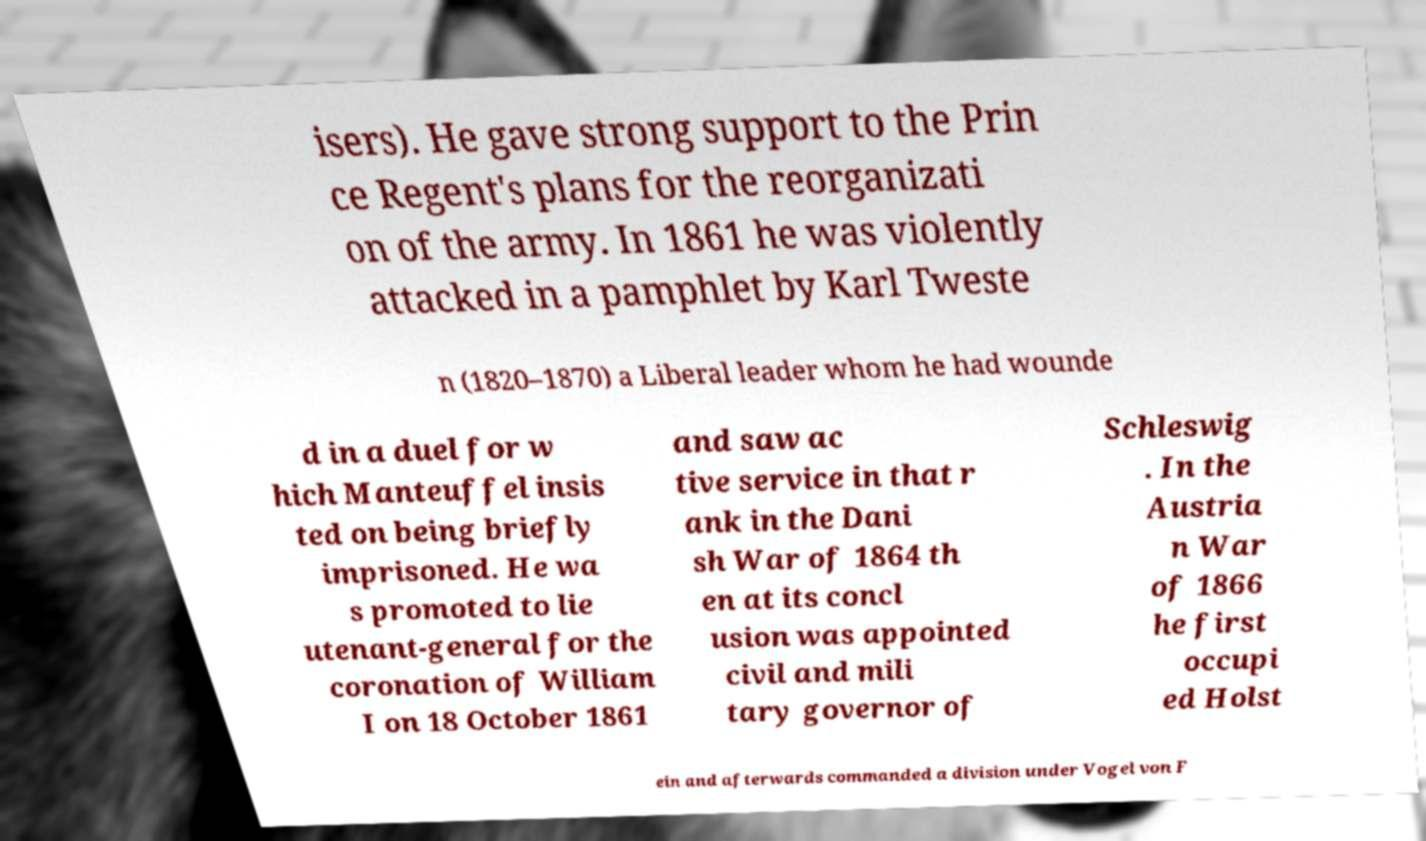What messages or text are displayed in this image? I need them in a readable, typed format. isers). He gave strong support to the Prin ce Regent's plans for the reorganizati on of the army. In 1861 he was violently attacked in a pamphlet by Karl Tweste n (1820–1870) a Liberal leader whom he had wounde d in a duel for w hich Manteuffel insis ted on being briefly imprisoned. He wa s promoted to lie utenant-general for the coronation of William I on 18 October 1861 and saw ac tive service in that r ank in the Dani sh War of 1864 th en at its concl usion was appointed civil and mili tary governor of Schleswig . In the Austria n War of 1866 he first occupi ed Holst ein and afterwards commanded a division under Vogel von F 